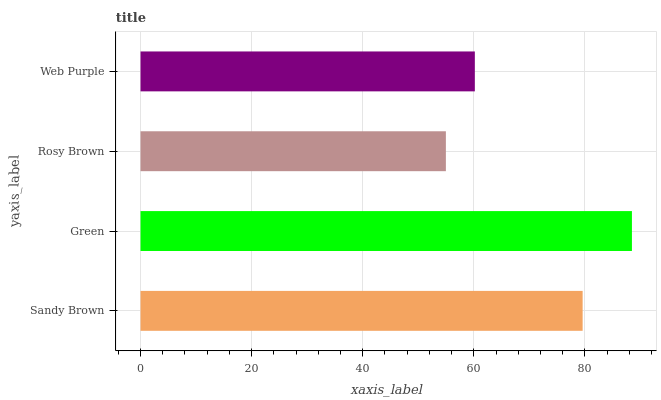Is Rosy Brown the minimum?
Answer yes or no. Yes. Is Green the maximum?
Answer yes or no. Yes. Is Green the minimum?
Answer yes or no. No. Is Rosy Brown the maximum?
Answer yes or no. No. Is Green greater than Rosy Brown?
Answer yes or no. Yes. Is Rosy Brown less than Green?
Answer yes or no. Yes. Is Rosy Brown greater than Green?
Answer yes or no. No. Is Green less than Rosy Brown?
Answer yes or no. No. Is Sandy Brown the high median?
Answer yes or no. Yes. Is Web Purple the low median?
Answer yes or no. Yes. Is Web Purple the high median?
Answer yes or no. No. Is Sandy Brown the low median?
Answer yes or no. No. 